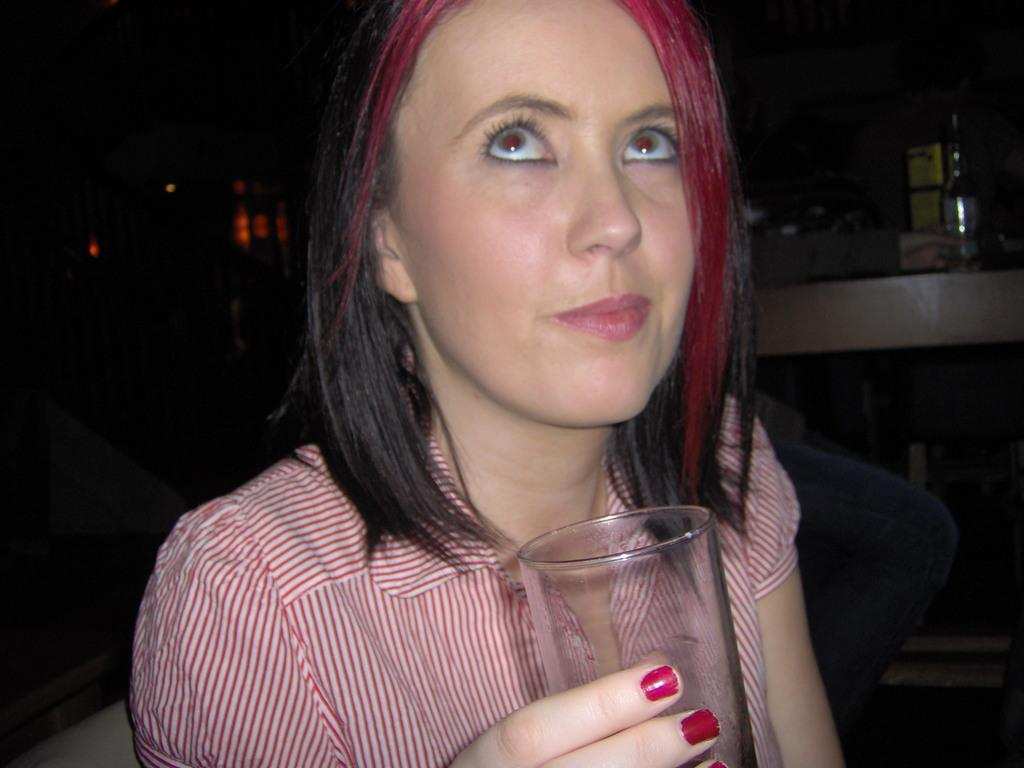Who is the main subject in the foreground of the image? There is a woman in the foreground of the image. What is the woman holding in the image? The woman is holding a glass. What can be seen in the background of the image? There are tables in the background of the image. Can you describe the person sitting at one of the tables? There is a person sitting at one of the tables, but their appearance cannot be determined from the image. What else is visible in the image? There is a bottle visible in the image. What type of hat is the woman wearing in the image? There is no hat visible on the woman in the image. What topic are the people discussing at the tables in the background? There is no discussion taking place in the image, and therefore no topic can be determined. 